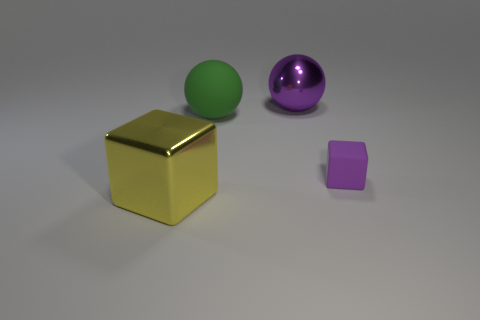Add 4 metallic cubes. How many objects exist? 8 Subtract 0 yellow balls. How many objects are left? 4 Subtract all big yellow things. Subtract all big green metallic cubes. How many objects are left? 3 Add 2 purple metal balls. How many purple metal balls are left? 3 Add 3 small purple blocks. How many small purple blocks exist? 4 